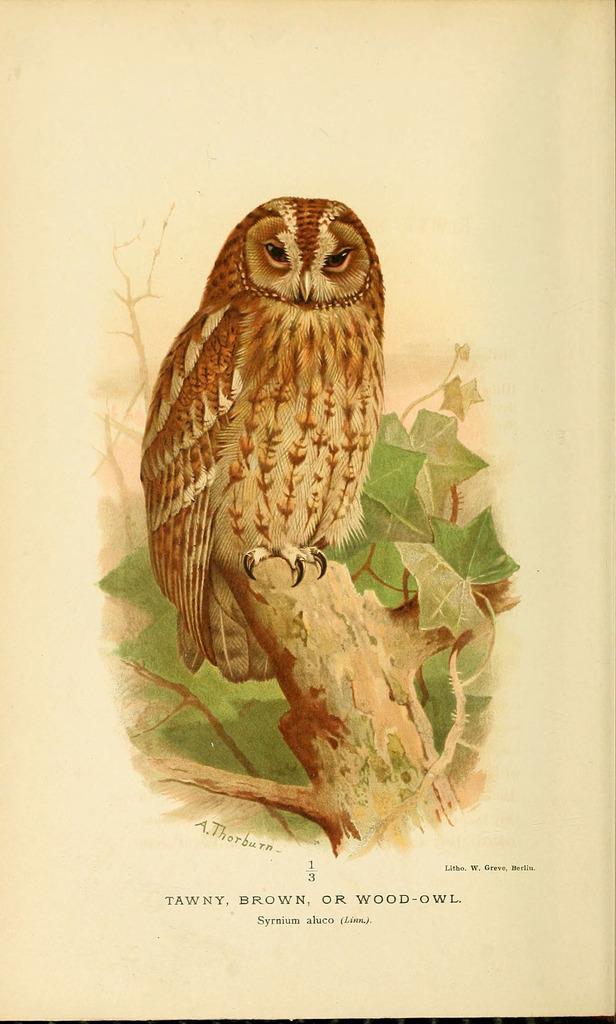Describe this image in one or two sentences. In this image there is a painting of an owl standing on the tree below that there is some text on the paper. 